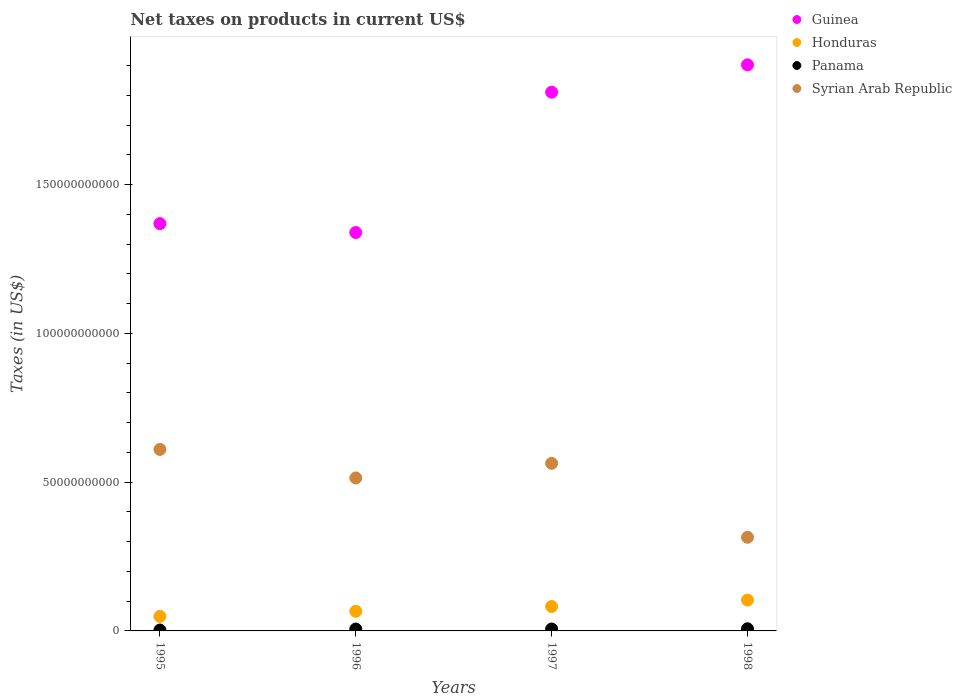How many different coloured dotlines are there?
Your answer should be compact. 4. What is the net taxes on products in Guinea in 1997?
Give a very brief answer. 1.81e+11. Across all years, what is the maximum net taxes on products in Guinea?
Provide a short and direct response. 1.90e+11. Across all years, what is the minimum net taxes on products in Syrian Arab Republic?
Make the answer very short. 3.15e+1. In which year was the net taxes on products in Honduras maximum?
Give a very brief answer. 1998. What is the total net taxes on products in Honduras in the graph?
Make the answer very short. 3.01e+1. What is the difference between the net taxes on products in Syrian Arab Republic in 1995 and that in 1997?
Ensure brevity in your answer.  4.68e+09. What is the difference between the net taxes on products in Panama in 1998 and the net taxes on products in Syrian Arab Republic in 1996?
Make the answer very short. -5.07e+1. What is the average net taxes on products in Guinea per year?
Your answer should be compact. 1.61e+11. In the year 1997, what is the difference between the net taxes on products in Panama and net taxes on products in Syrian Arab Republic?
Your answer should be very brief. -5.57e+1. What is the ratio of the net taxes on products in Panama in 1997 to that in 1998?
Give a very brief answer. 0.89. Is the net taxes on products in Panama in 1995 less than that in 1996?
Make the answer very short. Yes. What is the difference between the highest and the second highest net taxes on products in Panama?
Offer a terse response. 8.07e+07. What is the difference between the highest and the lowest net taxes on products in Honduras?
Ensure brevity in your answer.  5.49e+09. In how many years, is the net taxes on products in Panama greater than the average net taxes on products in Panama taken over all years?
Offer a terse response. 3. Is it the case that in every year, the sum of the net taxes on products in Panama and net taxes on products in Guinea  is greater than the sum of net taxes on products in Honduras and net taxes on products in Syrian Arab Republic?
Give a very brief answer. Yes. Is the net taxes on products in Panama strictly less than the net taxes on products in Honduras over the years?
Make the answer very short. Yes. How many years are there in the graph?
Provide a succinct answer. 4. Are the values on the major ticks of Y-axis written in scientific E-notation?
Provide a short and direct response. No. Where does the legend appear in the graph?
Provide a short and direct response. Top right. How are the legend labels stacked?
Offer a very short reply. Vertical. What is the title of the graph?
Keep it short and to the point. Net taxes on products in current US$. What is the label or title of the Y-axis?
Keep it short and to the point. Taxes (in US$). What is the Taxes (in US$) of Guinea in 1995?
Ensure brevity in your answer.  1.37e+11. What is the Taxes (in US$) of Honduras in 1995?
Make the answer very short. 4.88e+09. What is the Taxes (in US$) of Panama in 1995?
Provide a short and direct response. 3.01e+08. What is the Taxes (in US$) in Syrian Arab Republic in 1995?
Provide a succinct answer. 6.10e+1. What is the Taxes (in US$) in Guinea in 1996?
Make the answer very short. 1.34e+11. What is the Taxes (in US$) in Honduras in 1996?
Offer a terse response. 6.60e+09. What is the Taxes (in US$) of Panama in 1996?
Ensure brevity in your answer.  6.35e+08. What is the Taxes (in US$) in Syrian Arab Republic in 1996?
Keep it short and to the point. 5.14e+1. What is the Taxes (in US$) in Guinea in 1997?
Offer a terse response. 1.81e+11. What is the Taxes (in US$) in Honduras in 1997?
Your answer should be very brief. 8.21e+09. What is the Taxes (in US$) in Panama in 1997?
Ensure brevity in your answer.  6.44e+08. What is the Taxes (in US$) in Syrian Arab Republic in 1997?
Give a very brief answer. 5.63e+1. What is the Taxes (in US$) of Guinea in 1998?
Provide a succinct answer. 1.90e+11. What is the Taxes (in US$) in Honduras in 1998?
Make the answer very short. 1.04e+1. What is the Taxes (in US$) of Panama in 1998?
Provide a succinct answer. 7.25e+08. What is the Taxes (in US$) in Syrian Arab Republic in 1998?
Make the answer very short. 3.15e+1. Across all years, what is the maximum Taxes (in US$) of Guinea?
Your answer should be compact. 1.90e+11. Across all years, what is the maximum Taxes (in US$) of Honduras?
Ensure brevity in your answer.  1.04e+1. Across all years, what is the maximum Taxes (in US$) of Panama?
Give a very brief answer. 7.25e+08. Across all years, what is the maximum Taxes (in US$) of Syrian Arab Republic?
Provide a succinct answer. 6.10e+1. Across all years, what is the minimum Taxes (in US$) of Guinea?
Keep it short and to the point. 1.34e+11. Across all years, what is the minimum Taxes (in US$) in Honduras?
Your response must be concise. 4.88e+09. Across all years, what is the minimum Taxes (in US$) in Panama?
Make the answer very short. 3.01e+08. Across all years, what is the minimum Taxes (in US$) in Syrian Arab Republic?
Make the answer very short. 3.15e+1. What is the total Taxes (in US$) of Guinea in the graph?
Provide a short and direct response. 6.42e+11. What is the total Taxes (in US$) of Honduras in the graph?
Your answer should be very brief. 3.01e+1. What is the total Taxes (in US$) in Panama in the graph?
Ensure brevity in your answer.  2.31e+09. What is the total Taxes (in US$) of Syrian Arab Republic in the graph?
Give a very brief answer. 2.00e+11. What is the difference between the Taxes (in US$) of Guinea in 1995 and that in 1996?
Provide a succinct answer. 3.00e+09. What is the difference between the Taxes (in US$) in Honduras in 1995 and that in 1996?
Ensure brevity in your answer.  -1.72e+09. What is the difference between the Taxes (in US$) in Panama in 1995 and that in 1996?
Make the answer very short. -3.34e+08. What is the difference between the Taxes (in US$) of Syrian Arab Republic in 1995 and that in 1996?
Offer a very short reply. 9.59e+09. What is the difference between the Taxes (in US$) in Guinea in 1995 and that in 1997?
Provide a short and direct response. -4.42e+1. What is the difference between the Taxes (in US$) in Honduras in 1995 and that in 1997?
Your response must be concise. -3.33e+09. What is the difference between the Taxes (in US$) in Panama in 1995 and that in 1997?
Offer a terse response. -3.43e+08. What is the difference between the Taxes (in US$) in Syrian Arab Republic in 1995 and that in 1997?
Provide a short and direct response. 4.68e+09. What is the difference between the Taxes (in US$) in Guinea in 1995 and that in 1998?
Provide a succinct answer. -5.34e+1. What is the difference between the Taxes (in US$) of Honduras in 1995 and that in 1998?
Give a very brief answer. -5.49e+09. What is the difference between the Taxes (in US$) of Panama in 1995 and that in 1998?
Offer a very short reply. -4.24e+08. What is the difference between the Taxes (in US$) of Syrian Arab Republic in 1995 and that in 1998?
Provide a succinct answer. 2.95e+1. What is the difference between the Taxes (in US$) of Guinea in 1996 and that in 1997?
Provide a short and direct response. -4.72e+1. What is the difference between the Taxes (in US$) in Honduras in 1996 and that in 1997?
Make the answer very short. -1.61e+09. What is the difference between the Taxes (in US$) of Panama in 1996 and that in 1997?
Ensure brevity in your answer.  -9.80e+06. What is the difference between the Taxes (in US$) of Syrian Arab Republic in 1996 and that in 1997?
Offer a very short reply. -4.91e+09. What is the difference between the Taxes (in US$) of Guinea in 1996 and that in 1998?
Keep it short and to the point. -5.64e+1. What is the difference between the Taxes (in US$) in Honduras in 1996 and that in 1998?
Your response must be concise. -3.77e+09. What is the difference between the Taxes (in US$) of Panama in 1996 and that in 1998?
Keep it short and to the point. -9.05e+07. What is the difference between the Taxes (in US$) in Syrian Arab Republic in 1996 and that in 1998?
Offer a terse response. 1.99e+1. What is the difference between the Taxes (in US$) in Guinea in 1997 and that in 1998?
Your answer should be compact. -9.19e+09. What is the difference between the Taxes (in US$) in Honduras in 1997 and that in 1998?
Offer a very short reply. -2.16e+09. What is the difference between the Taxes (in US$) of Panama in 1997 and that in 1998?
Offer a very short reply. -8.07e+07. What is the difference between the Taxes (in US$) in Syrian Arab Republic in 1997 and that in 1998?
Make the answer very short. 2.49e+1. What is the difference between the Taxes (in US$) of Guinea in 1995 and the Taxes (in US$) of Honduras in 1996?
Your answer should be compact. 1.30e+11. What is the difference between the Taxes (in US$) in Guinea in 1995 and the Taxes (in US$) in Panama in 1996?
Provide a succinct answer. 1.36e+11. What is the difference between the Taxes (in US$) of Guinea in 1995 and the Taxes (in US$) of Syrian Arab Republic in 1996?
Make the answer very short. 8.55e+1. What is the difference between the Taxes (in US$) of Honduras in 1995 and the Taxes (in US$) of Panama in 1996?
Ensure brevity in your answer.  4.25e+09. What is the difference between the Taxes (in US$) of Honduras in 1995 and the Taxes (in US$) of Syrian Arab Republic in 1996?
Give a very brief answer. -4.65e+1. What is the difference between the Taxes (in US$) in Panama in 1995 and the Taxes (in US$) in Syrian Arab Republic in 1996?
Your response must be concise. -5.11e+1. What is the difference between the Taxes (in US$) in Guinea in 1995 and the Taxes (in US$) in Honduras in 1997?
Your answer should be very brief. 1.29e+11. What is the difference between the Taxes (in US$) of Guinea in 1995 and the Taxes (in US$) of Panama in 1997?
Your answer should be very brief. 1.36e+11. What is the difference between the Taxes (in US$) of Guinea in 1995 and the Taxes (in US$) of Syrian Arab Republic in 1997?
Keep it short and to the point. 8.06e+1. What is the difference between the Taxes (in US$) of Honduras in 1995 and the Taxes (in US$) of Panama in 1997?
Provide a short and direct response. 4.24e+09. What is the difference between the Taxes (in US$) in Honduras in 1995 and the Taxes (in US$) in Syrian Arab Republic in 1997?
Your answer should be very brief. -5.14e+1. What is the difference between the Taxes (in US$) in Panama in 1995 and the Taxes (in US$) in Syrian Arab Republic in 1997?
Your answer should be compact. -5.60e+1. What is the difference between the Taxes (in US$) of Guinea in 1995 and the Taxes (in US$) of Honduras in 1998?
Give a very brief answer. 1.27e+11. What is the difference between the Taxes (in US$) of Guinea in 1995 and the Taxes (in US$) of Panama in 1998?
Give a very brief answer. 1.36e+11. What is the difference between the Taxes (in US$) of Guinea in 1995 and the Taxes (in US$) of Syrian Arab Republic in 1998?
Give a very brief answer. 1.05e+11. What is the difference between the Taxes (in US$) of Honduras in 1995 and the Taxes (in US$) of Panama in 1998?
Provide a succinct answer. 4.16e+09. What is the difference between the Taxes (in US$) in Honduras in 1995 and the Taxes (in US$) in Syrian Arab Republic in 1998?
Provide a succinct answer. -2.66e+1. What is the difference between the Taxes (in US$) of Panama in 1995 and the Taxes (in US$) of Syrian Arab Republic in 1998?
Your answer should be very brief. -3.12e+1. What is the difference between the Taxes (in US$) in Guinea in 1996 and the Taxes (in US$) in Honduras in 1997?
Ensure brevity in your answer.  1.26e+11. What is the difference between the Taxes (in US$) in Guinea in 1996 and the Taxes (in US$) in Panama in 1997?
Keep it short and to the point. 1.33e+11. What is the difference between the Taxes (in US$) of Guinea in 1996 and the Taxes (in US$) of Syrian Arab Republic in 1997?
Give a very brief answer. 7.76e+1. What is the difference between the Taxes (in US$) in Honduras in 1996 and the Taxes (in US$) in Panama in 1997?
Make the answer very short. 5.96e+09. What is the difference between the Taxes (in US$) in Honduras in 1996 and the Taxes (in US$) in Syrian Arab Republic in 1997?
Make the answer very short. -4.97e+1. What is the difference between the Taxes (in US$) in Panama in 1996 and the Taxes (in US$) in Syrian Arab Republic in 1997?
Keep it short and to the point. -5.57e+1. What is the difference between the Taxes (in US$) of Guinea in 1996 and the Taxes (in US$) of Honduras in 1998?
Ensure brevity in your answer.  1.24e+11. What is the difference between the Taxes (in US$) of Guinea in 1996 and the Taxes (in US$) of Panama in 1998?
Offer a very short reply. 1.33e+11. What is the difference between the Taxes (in US$) in Guinea in 1996 and the Taxes (in US$) in Syrian Arab Republic in 1998?
Make the answer very short. 1.02e+11. What is the difference between the Taxes (in US$) in Honduras in 1996 and the Taxes (in US$) in Panama in 1998?
Keep it short and to the point. 5.88e+09. What is the difference between the Taxes (in US$) in Honduras in 1996 and the Taxes (in US$) in Syrian Arab Republic in 1998?
Ensure brevity in your answer.  -2.49e+1. What is the difference between the Taxes (in US$) of Panama in 1996 and the Taxes (in US$) of Syrian Arab Republic in 1998?
Keep it short and to the point. -3.08e+1. What is the difference between the Taxes (in US$) of Guinea in 1997 and the Taxes (in US$) of Honduras in 1998?
Provide a short and direct response. 1.71e+11. What is the difference between the Taxes (in US$) in Guinea in 1997 and the Taxes (in US$) in Panama in 1998?
Your response must be concise. 1.80e+11. What is the difference between the Taxes (in US$) of Guinea in 1997 and the Taxes (in US$) of Syrian Arab Republic in 1998?
Offer a terse response. 1.50e+11. What is the difference between the Taxes (in US$) in Honduras in 1997 and the Taxes (in US$) in Panama in 1998?
Make the answer very short. 7.49e+09. What is the difference between the Taxes (in US$) in Honduras in 1997 and the Taxes (in US$) in Syrian Arab Republic in 1998?
Offer a terse response. -2.33e+1. What is the difference between the Taxes (in US$) of Panama in 1997 and the Taxes (in US$) of Syrian Arab Republic in 1998?
Make the answer very short. -3.08e+1. What is the average Taxes (in US$) of Guinea per year?
Provide a short and direct response. 1.61e+11. What is the average Taxes (in US$) of Honduras per year?
Your response must be concise. 7.52e+09. What is the average Taxes (in US$) in Panama per year?
Provide a short and direct response. 5.76e+08. What is the average Taxes (in US$) in Syrian Arab Republic per year?
Your response must be concise. 5.01e+1. In the year 1995, what is the difference between the Taxes (in US$) of Guinea and Taxes (in US$) of Honduras?
Offer a very short reply. 1.32e+11. In the year 1995, what is the difference between the Taxes (in US$) of Guinea and Taxes (in US$) of Panama?
Offer a very short reply. 1.37e+11. In the year 1995, what is the difference between the Taxes (in US$) of Guinea and Taxes (in US$) of Syrian Arab Republic?
Your response must be concise. 7.59e+1. In the year 1995, what is the difference between the Taxes (in US$) in Honduras and Taxes (in US$) in Panama?
Provide a succinct answer. 4.58e+09. In the year 1995, what is the difference between the Taxes (in US$) in Honduras and Taxes (in US$) in Syrian Arab Republic?
Make the answer very short. -5.61e+1. In the year 1995, what is the difference between the Taxes (in US$) in Panama and Taxes (in US$) in Syrian Arab Republic?
Ensure brevity in your answer.  -6.07e+1. In the year 1996, what is the difference between the Taxes (in US$) in Guinea and Taxes (in US$) in Honduras?
Keep it short and to the point. 1.27e+11. In the year 1996, what is the difference between the Taxes (in US$) of Guinea and Taxes (in US$) of Panama?
Keep it short and to the point. 1.33e+11. In the year 1996, what is the difference between the Taxes (in US$) in Guinea and Taxes (in US$) in Syrian Arab Republic?
Provide a succinct answer. 8.25e+1. In the year 1996, what is the difference between the Taxes (in US$) in Honduras and Taxes (in US$) in Panama?
Your answer should be compact. 5.97e+09. In the year 1996, what is the difference between the Taxes (in US$) of Honduras and Taxes (in US$) of Syrian Arab Republic?
Offer a very short reply. -4.48e+1. In the year 1996, what is the difference between the Taxes (in US$) in Panama and Taxes (in US$) in Syrian Arab Republic?
Offer a very short reply. -5.08e+1. In the year 1997, what is the difference between the Taxes (in US$) of Guinea and Taxes (in US$) of Honduras?
Ensure brevity in your answer.  1.73e+11. In the year 1997, what is the difference between the Taxes (in US$) of Guinea and Taxes (in US$) of Panama?
Offer a very short reply. 1.80e+11. In the year 1997, what is the difference between the Taxes (in US$) of Guinea and Taxes (in US$) of Syrian Arab Republic?
Offer a terse response. 1.25e+11. In the year 1997, what is the difference between the Taxes (in US$) in Honduras and Taxes (in US$) in Panama?
Provide a succinct answer. 7.57e+09. In the year 1997, what is the difference between the Taxes (in US$) of Honduras and Taxes (in US$) of Syrian Arab Republic?
Ensure brevity in your answer.  -4.81e+1. In the year 1997, what is the difference between the Taxes (in US$) of Panama and Taxes (in US$) of Syrian Arab Republic?
Your response must be concise. -5.57e+1. In the year 1998, what is the difference between the Taxes (in US$) of Guinea and Taxes (in US$) of Honduras?
Offer a very short reply. 1.80e+11. In the year 1998, what is the difference between the Taxes (in US$) in Guinea and Taxes (in US$) in Panama?
Your response must be concise. 1.90e+11. In the year 1998, what is the difference between the Taxes (in US$) in Guinea and Taxes (in US$) in Syrian Arab Republic?
Keep it short and to the point. 1.59e+11. In the year 1998, what is the difference between the Taxes (in US$) of Honduras and Taxes (in US$) of Panama?
Provide a succinct answer. 9.64e+09. In the year 1998, what is the difference between the Taxes (in US$) in Honduras and Taxes (in US$) in Syrian Arab Republic?
Offer a terse response. -2.11e+1. In the year 1998, what is the difference between the Taxes (in US$) of Panama and Taxes (in US$) of Syrian Arab Republic?
Provide a succinct answer. -3.07e+1. What is the ratio of the Taxes (in US$) of Guinea in 1995 to that in 1996?
Ensure brevity in your answer.  1.02. What is the ratio of the Taxes (in US$) in Honduras in 1995 to that in 1996?
Provide a succinct answer. 0.74. What is the ratio of the Taxes (in US$) in Panama in 1995 to that in 1996?
Your answer should be very brief. 0.47. What is the ratio of the Taxes (in US$) in Syrian Arab Republic in 1995 to that in 1996?
Offer a very short reply. 1.19. What is the ratio of the Taxes (in US$) in Guinea in 1995 to that in 1997?
Offer a very short reply. 0.76. What is the ratio of the Taxes (in US$) of Honduras in 1995 to that in 1997?
Give a very brief answer. 0.59. What is the ratio of the Taxes (in US$) in Panama in 1995 to that in 1997?
Provide a short and direct response. 0.47. What is the ratio of the Taxes (in US$) of Syrian Arab Republic in 1995 to that in 1997?
Ensure brevity in your answer.  1.08. What is the ratio of the Taxes (in US$) of Guinea in 1995 to that in 1998?
Offer a terse response. 0.72. What is the ratio of the Taxes (in US$) of Honduras in 1995 to that in 1998?
Ensure brevity in your answer.  0.47. What is the ratio of the Taxes (in US$) in Panama in 1995 to that in 1998?
Provide a succinct answer. 0.42. What is the ratio of the Taxes (in US$) of Syrian Arab Republic in 1995 to that in 1998?
Your response must be concise. 1.94. What is the ratio of the Taxes (in US$) in Guinea in 1996 to that in 1997?
Offer a very short reply. 0.74. What is the ratio of the Taxes (in US$) in Honduras in 1996 to that in 1997?
Your answer should be very brief. 0.8. What is the ratio of the Taxes (in US$) in Panama in 1996 to that in 1997?
Provide a succinct answer. 0.98. What is the ratio of the Taxes (in US$) in Syrian Arab Republic in 1996 to that in 1997?
Ensure brevity in your answer.  0.91. What is the ratio of the Taxes (in US$) in Guinea in 1996 to that in 1998?
Provide a short and direct response. 0.7. What is the ratio of the Taxes (in US$) of Honduras in 1996 to that in 1998?
Offer a very short reply. 0.64. What is the ratio of the Taxes (in US$) of Panama in 1996 to that in 1998?
Your response must be concise. 0.88. What is the ratio of the Taxes (in US$) in Syrian Arab Republic in 1996 to that in 1998?
Your answer should be compact. 1.63. What is the ratio of the Taxes (in US$) of Guinea in 1997 to that in 1998?
Your answer should be very brief. 0.95. What is the ratio of the Taxes (in US$) in Honduras in 1997 to that in 1998?
Make the answer very short. 0.79. What is the ratio of the Taxes (in US$) in Panama in 1997 to that in 1998?
Offer a very short reply. 0.89. What is the ratio of the Taxes (in US$) in Syrian Arab Republic in 1997 to that in 1998?
Provide a short and direct response. 1.79. What is the difference between the highest and the second highest Taxes (in US$) in Guinea?
Offer a very short reply. 9.19e+09. What is the difference between the highest and the second highest Taxes (in US$) of Honduras?
Your answer should be compact. 2.16e+09. What is the difference between the highest and the second highest Taxes (in US$) in Panama?
Make the answer very short. 8.07e+07. What is the difference between the highest and the second highest Taxes (in US$) of Syrian Arab Republic?
Your answer should be compact. 4.68e+09. What is the difference between the highest and the lowest Taxes (in US$) in Guinea?
Keep it short and to the point. 5.64e+1. What is the difference between the highest and the lowest Taxes (in US$) of Honduras?
Your response must be concise. 5.49e+09. What is the difference between the highest and the lowest Taxes (in US$) in Panama?
Keep it short and to the point. 4.24e+08. What is the difference between the highest and the lowest Taxes (in US$) of Syrian Arab Republic?
Your answer should be very brief. 2.95e+1. 